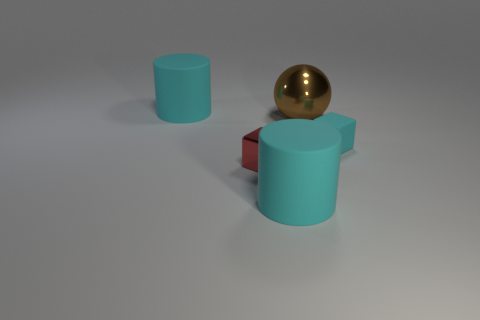Is there anything else that has the same color as the rubber block?
Make the answer very short. Yes. Do the big brown object and the tiny cyan thing have the same material?
Provide a succinct answer. No. Are there any tiny red metallic objects that have the same shape as the small cyan object?
Your answer should be very brief. Yes. Does the rubber object behind the brown object have the same color as the tiny rubber cube?
Make the answer very short. Yes. There is a metal thing behind the red thing; does it have the same size as the block that is right of the red shiny object?
Your answer should be compact. No. What size is the red thing that is the same material as the large brown object?
Ensure brevity in your answer.  Small. What number of objects are both right of the tiny metal thing and in front of the big brown object?
Your response must be concise. 2. What number of objects are red objects or large cyan rubber objects to the right of the small red thing?
Your answer should be compact. 2. What is the color of the object that is to the left of the metallic cube?
Provide a succinct answer. Cyan. How many things are cyan cylinders that are on the left side of the big brown shiny thing or spheres?
Make the answer very short. 3. 